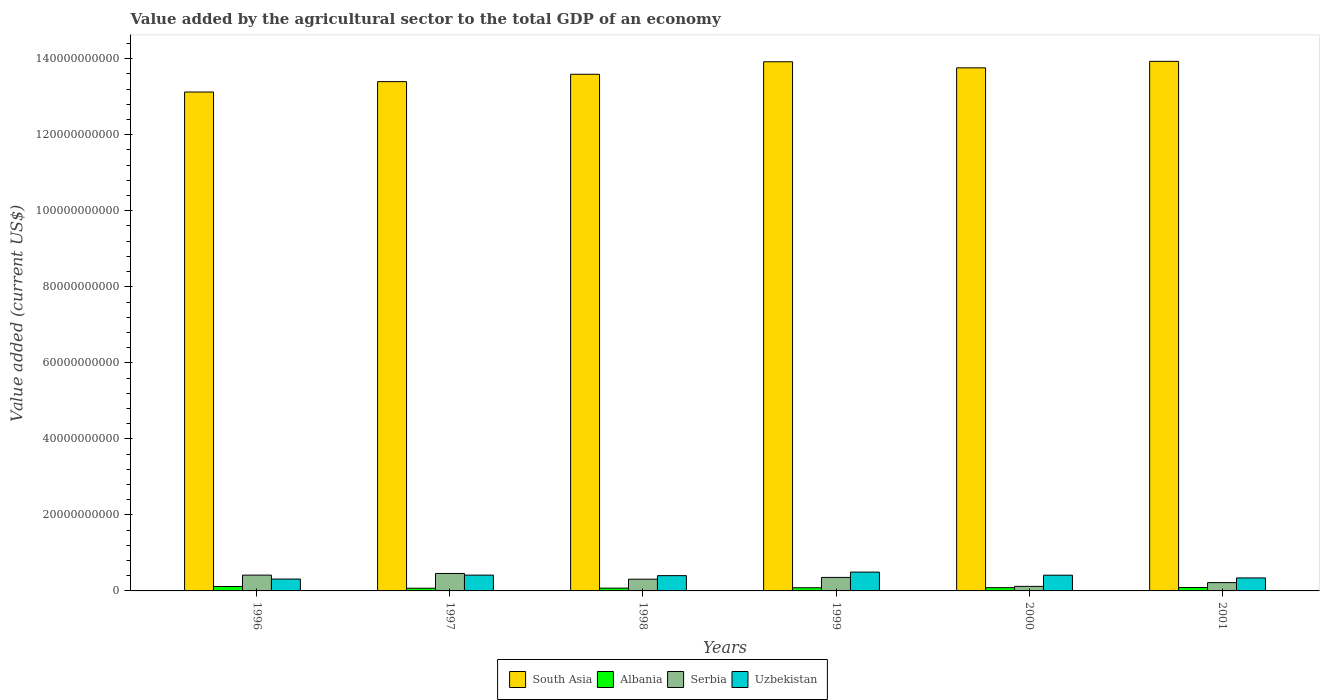How many bars are there on the 4th tick from the left?
Provide a short and direct response. 4. How many bars are there on the 4th tick from the right?
Your answer should be very brief. 4. What is the label of the 2nd group of bars from the left?
Your response must be concise. 1997. In how many cases, is the number of bars for a given year not equal to the number of legend labels?
Ensure brevity in your answer.  0. What is the value added by the agricultural sector to the total GDP in Uzbekistan in 1997?
Provide a succinct answer. 4.16e+09. Across all years, what is the maximum value added by the agricultural sector to the total GDP in Uzbekistan?
Provide a succinct answer. 4.96e+09. Across all years, what is the minimum value added by the agricultural sector to the total GDP in Uzbekistan?
Your answer should be compact. 3.12e+09. In which year was the value added by the agricultural sector to the total GDP in Serbia minimum?
Keep it short and to the point. 2000. What is the total value added by the agricultural sector to the total GDP in Albania in the graph?
Your response must be concise. 5.19e+09. What is the difference between the value added by the agricultural sector to the total GDP in Serbia in 1999 and that in 2001?
Offer a terse response. 1.37e+09. What is the difference between the value added by the agricultural sector to the total GDP in Albania in 1999 and the value added by the agricultural sector to the total GDP in Uzbekistan in 1996?
Provide a succinct answer. -2.29e+09. What is the average value added by the agricultural sector to the total GDP in Albania per year?
Your answer should be very brief. 8.65e+08. In the year 1996, what is the difference between the value added by the agricultural sector to the total GDP in Serbia and value added by the agricultural sector to the total GDP in Uzbekistan?
Ensure brevity in your answer.  1.04e+09. What is the ratio of the value added by the agricultural sector to the total GDP in Serbia in 1998 to that in 1999?
Offer a very short reply. 0.87. Is the value added by the agricultural sector to the total GDP in Albania in 1998 less than that in 2000?
Provide a succinct answer. Yes. What is the difference between the highest and the second highest value added by the agricultural sector to the total GDP in Albania?
Provide a short and direct response. 2.74e+08. What is the difference between the highest and the lowest value added by the agricultural sector to the total GDP in Uzbekistan?
Provide a short and direct response. 1.84e+09. Is the sum of the value added by the agricultural sector to the total GDP in Serbia in 1999 and 2001 greater than the maximum value added by the agricultural sector to the total GDP in South Asia across all years?
Make the answer very short. No. Is it the case that in every year, the sum of the value added by the agricultural sector to the total GDP in South Asia and value added by the agricultural sector to the total GDP in Albania is greater than the sum of value added by the agricultural sector to the total GDP in Serbia and value added by the agricultural sector to the total GDP in Uzbekistan?
Keep it short and to the point. Yes. What does the 1st bar from the right in 2000 represents?
Keep it short and to the point. Uzbekistan. How many bars are there?
Offer a very short reply. 24. Are all the bars in the graph horizontal?
Provide a short and direct response. No. Where does the legend appear in the graph?
Ensure brevity in your answer.  Bottom center. What is the title of the graph?
Offer a very short reply. Value added by the agricultural sector to the total GDP of an economy. What is the label or title of the X-axis?
Ensure brevity in your answer.  Years. What is the label or title of the Y-axis?
Keep it short and to the point. Value added (current US$). What is the Value added (current US$) in South Asia in 1996?
Offer a terse response. 1.31e+11. What is the Value added (current US$) in Albania in 1996?
Offer a terse response. 1.17e+09. What is the Value added (current US$) of Serbia in 1996?
Offer a very short reply. 4.16e+09. What is the Value added (current US$) in Uzbekistan in 1996?
Your answer should be very brief. 3.12e+09. What is the Value added (current US$) in South Asia in 1997?
Ensure brevity in your answer.  1.34e+11. What is the Value added (current US$) of Albania in 1997?
Give a very brief answer. 7.12e+08. What is the Value added (current US$) of Serbia in 1997?
Offer a terse response. 4.59e+09. What is the Value added (current US$) of Uzbekistan in 1997?
Keep it short and to the point. 4.16e+09. What is the Value added (current US$) of South Asia in 1998?
Your answer should be compact. 1.36e+11. What is the Value added (current US$) in Albania in 1998?
Your answer should be compact. 7.33e+08. What is the Value added (current US$) in Serbia in 1998?
Make the answer very short. 3.09e+09. What is the Value added (current US$) of Uzbekistan in 1998?
Provide a short and direct response. 4.02e+09. What is the Value added (current US$) of South Asia in 1999?
Your response must be concise. 1.39e+11. What is the Value added (current US$) of Albania in 1999?
Ensure brevity in your answer.  8.33e+08. What is the Value added (current US$) in Serbia in 1999?
Keep it short and to the point. 3.55e+09. What is the Value added (current US$) in Uzbekistan in 1999?
Your response must be concise. 4.96e+09. What is the Value added (current US$) of South Asia in 2000?
Your answer should be compact. 1.38e+11. What is the Value added (current US$) in Albania in 2000?
Keep it short and to the point. 8.53e+08. What is the Value added (current US$) of Serbia in 2000?
Your response must be concise. 1.20e+09. What is the Value added (current US$) of Uzbekistan in 2000?
Make the answer very short. 4.14e+09. What is the Value added (current US$) of South Asia in 2001?
Provide a succinct answer. 1.39e+11. What is the Value added (current US$) of Albania in 2001?
Give a very brief answer. 8.91e+08. What is the Value added (current US$) of Serbia in 2001?
Your answer should be very brief. 2.19e+09. What is the Value added (current US$) of Uzbekistan in 2001?
Make the answer very short. 3.42e+09. Across all years, what is the maximum Value added (current US$) of South Asia?
Offer a terse response. 1.39e+11. Across all years, what is the maximum Value added (current US$) in Albania?
Keep it short and to the point. 1.17e+09. Across all years, what is the maximum Value added (current US$) in Serbia?
Offer a terse response. 4.59e+09. Across all years, what is the maximum Value added (current US$) in Uzbekistan?
Keep it short and to the point. 4.96e+09. Across all years, what is the minimum Value added (current US$) of South Asia?
Give a very brief answer. 1.31e+11. Across all years, what is the minimum Value added (current US$) in Albania?
Make the answer very short. 7.12e+08. Across all years, what is the minimum Value added (current US$) in Serbia?
Your response must be concise. 1.20e+09. Across all years, what is the minimum Value added (current US$) in Uzbekistan?
Keep it short and to the point. 3.12e+09. What is the total Value added (current US$) in South Asia in the graph?
Keep it short and to the point. 8.17e+11. What is the total Value added (current US$) in Albania in the graph?
Ensure brevity in your answer.  5.19e+09. What is the total Value added (current US$) of Serbia in the graph?
Offer a terse response. 1.88e+1. What is the total Value added (current US$) of Uzbekistan in the graph?
Your answer should be very brief. 2.38e+1. What is the difference between the Value added (current US$) of South Asia in 1996 and that in 1997?
Your answer should be very brief. -2.74e+09. What is the difference between the Value added (current US$) in Albania in 1996 and that in 1997?
Make the answer very short. 4.53e+08. What is the difference between the Value added (current US$) of Serbia in 1996 and that in 1997?
Ensure brevity in your answer.  -4.31e+08. What is the difference between the Value added (current US$) of Uzbekistan in 1996 and that in 1997?
Your answer should be compact. -1.04e+09. What is the difference between the Value added (current US$) of South Asia in 1996 and that in 1998?
Ensure brevity in your answer.  -4.67e+09. What is the difference between the Value added (current US$) of Albania in 1996 and that in 1998?
Keep it short and to the point. 4.32e+08. What is the difference between the Value added (current US$) in Serbia in 1996 and that in 1998?
Your response must be concise. 1.07e+09. What is the difference between the Value added (current US$) in Uzbekistan in 1996 and that in 1998?
Your response must be concise. -8.97e+08. What is the difference between the Value added (current US$) of South Asia in 1996 and that in 1999?
Ensure brevity in your answer.  -7.96e+09. What is the difference between the Value added (current US$) of Albania in 1996 and that in 1999?
Provide a succinct answer. 3.32e+08. What is the difference between the Value added (current US$) in Serbia in 1996 and that in 1999?
Your answer should be compact. 6.08e+08. What is the difference between the Value added (current US$) of Uzbekistan in 1996 and that in 1999?
Make the answer very short. -1.84e+09. What is the difference between the Value added (current US$) of South Asia in 1996 and that in 2000?
Your answer should be compact. -6.36e+09. What is the difference between the Value added (current US$) of Albania in 1996 and that in 2000?
Offer a very short reply. 3.12e+08. What is the difference between the Value added (current US$) in Serbia in 1996 and that in 2000?
Ensure brevity in your answer.  2.96e+09. What is the difference between the Value added (current US$) in Uzbekistan in 1996 and that in 2000?
Provide a succinct answer. -1.02e+09. What is the difference between the Value added (current US$) of South Asia in 1996 and that in 2001?
Offer a terse response. -8.07e+09. What is the difference between the Value added (current US$) of Albania in 1996 and that in 2001?
Offer a very short reply. 2.74e+08. What is the difference between the Value added (current US$) in Serbia in 1996 and that in 2001?
Your response must be concise. 1.97e+09. What is the difference between the Value added (current US$) in Uzbekistan in 1996 and that in 2001?
Your response must be concise. -2.98e+08. What is the difference between the Value added (current US$) of South Asia in 1997 and that in 1998?
Give a very brief answer. -1.94e+09. What is the difference between the Value added (current US$) of Albania in 1997 and that in 1998?
Your answer should be compact. -2.05e+07. What is the difference between the Value added (current US$) in Serbia in 1997 and that in 1998?
Offer a terse response. 1.50e+09. What is the difference between the Value added (current US$) in Uzbekistan in 1997 and that in 1998?
Your response must be concise. 1.41e+08. What is the difference between the Value added (current US$) of South Asia in 1997 and that in 1999?
Offer a very short reply. -5.22e+09. What is the difference between the Value added (current US$) in Albania in 1997 and that in 1999?
Provide a succinct answer. -1.20e+08. What is the difference between the Value added (current US$) of Serbia in 1997 and that in 1999?
Keep it short and to the point. 1.04e+09. What is the difference between the Value added (current US$) in Uzbekistan in 1997 and that in 1999?
Your answer should be very brief. -7.99e+08. What is the difference between the Value added (current US$) of South Asia in 1997 and that in 2000?
Your answer should be very brief. -3.62e+09. What is the difference between the Value added (current US$) in Albania in 1997 and that in 2000?
Provide a succinct answer. -1.41e+08. What is the difference between the Value added (current US$) of Serbia in 1997 and that in 2000?
Your response must be concise. 3.39e+09. What is the difference between the Value added (current US$) of Uzbekistan in 1997 and that in 2000?
Keep it short and to the point. 2.19e+07. What is the difference between the Value added (current US$) of South Asia in 1997 and that in 2001?
Provide a short and direct response. -5.33e+09. What is the difference between the Value added (current US$) of Albania in 1997 and that in 2001?
Make the answer very short. -1.79e+08. What is the difference between the Value added (current US$) of Serbia in 1997 and that in 2001?
Make the answer very short. 2.40e+09. What is the difference between the Value added (current US$) of Uzbekistan in 1997 and that in 2001?
Ensure brevity in your answer.  7.40e+08. What is the difference between the Value added (current US$) in South Asia in 1998 and that in 1999?
Your response must be concise. -3.28e+09. What is the difference between the Value added (current US$) of Albania in 1998 and that in 1999?
Give a very brief answer. -9.98e+07. What is the difference between the Value added (current US$) in Serbia in 1998 and that in 1999?
Give a very brief answer. -4.63e+08. What is the difference between the Value added (current US$) of Uzbekistan in 1998 and that in 1999?
Provide a succinct answer. -9.40e+08. What is the difference between the Value added (current US$) in South Asia in 1998 and that in 2000?
Provide a short and direct response. -1.69e+09. What is the difference between the Value added (current US$) of Albania in 1998 and that in 2000?
Ensure brevity in your answer.  -1.21e+08. What is the difference between the Value added (current US$) of Serbia in 1998 and that in 2000?
Provide a succinct answer. 1.89e+09. What is the difference between the Value added (current US$) of Uzbekistan in 1998 and that in 2000?
Your answer should be compact. -1.19e+08. What is the difference between the Value added (current US$) of South Asia in 1998 and that in 2001?
Give a very brief answer. -3.40e+09. What is the difference between the Value added (current US$) in Albania in 1998 and that in 2001?
Provide a short and direct response. -1.58e+08. What is the difference between the Value added (current US$) of Serbia in 1998 and that in 2001?
Your response must be concise. 9.02e+08. What is the difference between the Value added (current US$) in Uzbekistan in 1998 and that in 2001?
Ensure brevity in your answer.  6.00e+08. What is the difference between the Value added (current US$) in South Asia in 1999 and that in 2000?
Offer a very short reply. 1.60e+09. What is the difference between the Value added (current US$) of Albania in 1999 and that in 2000?
Your answer should be very brief. -2.08e+07. What is the difference between the Value added (current US$) in Serbia in 1999 and that in 2000?
Offer a terse response. 2.35e+09. What is the difference between the Value added (current US$) of Uzbekistan in 1999 and that in 2000?
Ensure brevity in your answer.  8.21e+08. What is the difference between the Value added (current US$) in South Asia in 1999 and that in 2001?
Give a very brief answer. -1.12e+08. What is the difference between the Value added (current US$) of Albania in 1999 and that in 2001?
Offer a terse response. -5.86e+07. What is the difference between the Value added (current US$) of Serbia in 1999 and that in 2001?
Offer a very short reply. 1.37e+09. What is the difference between the Value added (current US$) of Uzbekistan in 1999 and that in 2001?
Provide a short and direct response. 1.54e+09. What is the difference between the Value added (current US$) in South Asia in 2000 and that in 2001?
Offer a very short reply. -1.71e+09. What is the difference between the Value added (current US$) in Albania in 2000 and that in 2001?
Provide a succinct answer. -3.78e+07. What is the difference between the Value added (current US$) in Serbia in 2000 and that in 2001?
Your response must be concise. -9.86e+08. What is the difference between the Value added (current US$) in Uzbekistan in 2000 and that in 2001?
Ensure brevity in your answer.  7.19e+08. What is the difference between the Value added (current US$) of South Asia in 1996 and the Value added (current US$) of Albania in 1997?
Provide a succinct answer. 1.31e+11. What is the difference between the Value added (current US$) of South Asia in 1996 and the Value added (current US$) of Serbia in 1997?
Keep it short and to the point. 1.27e+11. What is the difference between the Value added (current US$) in South Asia in 1996 and the Value added (current US$) in Uzbekistan in 1997?
Your answer should be compact. 1.27e+11. What is the difference between the Value added (current US$) in Albania in 1996 and the Value added (current US$) in Serbia in 1997?
Provide a short and direct response. -3.43e+09. What is the difference between the Value added (current US$) in Albania in 1996 and the Value added (current US$) in Uzbekistan in 1997?
Provide a short and direct response. -2.99e+09. What is the difference between the Value added (current US$) in Serbia in 1996 and the Value added (current US$) in Uzbekistan in 1997?
Give a very brief answer. 1.05e+06. What is the difference between the Value added (current US$) of South Asia in 1996 and the Value added (current US$) of Albania in 1998?
Your response must be concise. 1.31e+11. What is the difference between the Value added (current US$) of South Asia in 1996 and the Value added (current US$) of Serbia in 1998?
Your answer should be compact. 1.28e+11. What is the difference between the Value added (current US$) in South Asia in 1996 and the Value added (current US$) in Uzbekistan in 1998?
Keep it short and to the point. 1.27e+11. What is the difference between the Value added (current US$) in Albania in 1996 and the Value added (current US$) in Serbia in 1998?
Provide a succinct answer. -1.92e+09. What is the difference between the Value added (current US$) in Albania in 1996 and the Value added (current US$) in Uzbekistan in 1998?
Provide a short and direct response. -2.85e+09. What is the difference between the Value added (current US$) in Serbia in 1996 and the Value added (current US$) in Uzbekistan in 1998?
Ensure brevity in your answer.  1.42e+08. What is the difference between the Value added (current US$) in South Asia in 1996 and the Value added (current US$) in Albania in 1999?
Your answer should be very brief. 1.30e+11. What is the difference between the Value added (current US$) of South Asia in 1996 and the Value added (current US$) of Serbia in 1999?
Offer a terse response. 1.28e+11. What is the difference between the Value added (current US$) in South Asia in 1996 and the Value added (current US$) in Uzbekistan in 1999?
Keep it short and to the point. 1.26e+11. What is the difference between the Value added (current US$) of Albania in 1996 and the Value added (current US$) of Serbia in 1999?
Make the answer very short. -2.39e+09. What is the difference between the Value added (current US$) of Albania in 1996 and the Value added (current US$) of Uzbekistan in 1999?
Provide a short and direct response. -3.79e+09. What is the difference between the Value added (current US$) in Serbia in 1996 and the Value added (current US$) in Uzbekistan in 1999?
Your answer should be compact. -7.98e+08. What is the difference between the Value added (current US$) of South Asia in 1996 and the Value added (current US$) of Albania in 2000?
Provide a succinct answer. 1.30e+11. What is the difference between the Value added (current US$) of South Asia in 1996 and the Value added (current US$) of Serbia in 2000?
Ensure brevity in your answer.  1.30e+11. What is the difference between the Value added (current US$) of South Asia in 1996 and the Value added (current US$) of Uzbekistan in 2000?
Your answer should be compact. 1.27e+11. What is the difference between the Value added (current US$) of Albania in 1996 and the Value added (current US$) of Serbia in 2000?
Your response must be concise. -3.46e+07. What is the difference between the Value added (current US$) of Albania in 1996 and the Value added (current US$) of Uzbekistan in 2000?
Offer a very short reply. -2.97e+09. What is the difference between the Value added (current US$) in Serbia in 1996 and the Value added (current US$) in Uzbekistan in 2000?
Offer a terse response. 2.30e+07. What is the difference between the Value added (current US$) in South Asia in 1996 and the Value added (current US$) in Albania in 2001?
Provide a short and direct response. 1.30e+11. What is the difference between the Value added (current US$) in South Asia in 1996 and the Value added (current US$) in Serbia in 2001?
Provide a short and direct response. 1.29e+11. What is the difference between the Value added (current US$) in South Asia in 1996 and the Value added (current US$) in Uzbekistan in 2001?
Ensure brevity in your answer.  1.28e+11. What is the difference between the Value added (current US$) in Albania in 1996 and the Value added (current US$) in Serbia in 2001?
Make the answer very short. -1.02e+09. What is the difference between the Value added (current US$) of Albania in 1996 and the Value added (current US$) of Uzbekistan in 2001?
Offer a very short reply. -2.25e+09. What is the difference between the Value added (current US$) of Serbia in 1996 and the Value added (current US$) of Uzbekistan in 2001?
Make the answer very short. 7.41e+08. What is the difference between the Value added (current US$) in South Asia in 1997 and the Value added (current US$) in Albania in 1998?
Offer a terse response. 1.33e+11. What is the difference between the Value added (current US$) of South Asia in 1997 and the Value added (current US$) of Serbia in 1998?
Your response must be concise. 1.31e+11. What is the difference between the Value added (current US$) in South Asia in 1997 and the Value added (current US$) in Uzbekistan in 1998?
Keep it short and to the point. 1.30e+11. What is the difference between the Value added (current US$) in Albania in 1997 and the Value added (current US$) in Serbia in 1998?
Give a very brief answer. -2.38e+09. What is the difference between the Value added (current US$) in Albania in 1997 and the Value added (current US$) in Uzbekistan in 1998?
Your answer should be very brief. -3.30e+09. What is the difference between the Value added (current US$) in Serbia in 1997 and the Value added (current US$) in Uzbekistan in 1998?
Provide a succinct answer. 5.73e+08. What is the difference between the Value added (current US$) in South Asia in 1997 and the Value added (current US$) in Albania in 1999?
Make the answer very short. 1.33e+11. What is the difference between the Value added (current US$) of South Asia in 1997 and the Value added (current US$) of Serbia in 1999?
Your answer should be compact. 1.30e+11. What is the difference between the Value added (current US$) of South Asia in 1997 and the Value added (current US$) of Uzbekistan in 1999?
Your response must be concise. 1.29e+11. What is the difference between the Value added (current US$) of Albania in 1997 and the Value added (current US$) of Serbia in 1999?
Provide a short and direct response. -2.84e+09. What is the difference between the Value added (current US$) of Albania in 1997 and the Value added (current US$) of Uzbekistan in 1999?
Your answer should be very brief. -4.24e+09. What is the difference between the Value added (current US$) in Serbia in 1997 and the Value added (current US$) in Uzbekistan in 1999?
Make the answer very short. -3.66e+08. What is the difference between the Value added (current US$) in South Asia in 1997 and the Value added (current US$) in Albania in 2000?
Offer a terse response. 1.33e+11. What is the difference between the Value added (current US$) in South Asia in 1997 and the Value added (current US$) in Serbia in 2000?
Offer a terse response. 1.33e+11. What is the difference between the Value added (current US$) in South Asia in 1997 and the Value added (current US$) in Uzbekistan in 2000?
Your answer should be very brief. 1.30e+11. What is the difference between the Value added (current US$) in Albania in 1997 and the Value added (current US$) in Serbia in 2000?
Keep it short and to the point. -4.87e+08. What is the difference between the Value added (current US$) in Albania in 1997 and the Value added (current US$) in Uzbekistan in 2000?
Provide a short and direct response. -3.42e+09. What is the difference between the Value added (current US$) of Serbia in 1997 and the Value added (current US$) of Uzbekistan in 2000?
Offer a terse response. 4.54e+08. What is the difference between the Value added (current US$) in South Asia in 1997 and the Value added (current US$) in Albania in 2001?
Your answer should be compact. 1.33e+11. What is the difference between the Value added (current US$) of South Asia in 1997 and the Value added (current US$) of Serbia in 2001?
Make the answer very short. 1.32e+11. What is the difference between the Value added (current US$) in South Asia in 1997 and the Value added (current US$) in Uzbekistan in 2001?
Keep it short and to the point. 1.31e+11. What is the difference between the Value added (current US$) in Albania in 1997 and the Value added (current US$) in Serbia in 2001?
Keep it short and to the point. -1.47e+09. What is the difference between the Value added (current US$) in Albania in 1997 and the Value added (current US$) in Uzbekistan in 2001?
Your answer should be compact. -2.70e+09. What is the difference between the Value added (current US$) in Serbia in 1997 and the Value added (current US$) in Uzbekistan in 2001?
Ensure brevity in your answer.  1.17e+09. What is the difference between the Value added (current US$) of South Asia in 1998 and the Value added (current US$) of Albania in 1999?
Offer a terse response. 1.35e+11. What is the difference between the Value added (current US$) in South Asia in 1998 and the Value added (current US$) in Serbia in 1999?
Provide a short and direct response. 1.32e+11. What is the difference between the Value added (current US$) of South Asia in 1998 and the Value added (current US$) of Uzbekistan in 1999?
Keep it short and to the point. 1.31e+11. What is the difference between the Value added (current US$) of Albania in 1998 and the Value added (current US$) of Serbia in 1999?
Your answer should be very brief. -2.82e+09. What is the difference between the Value added (current US$) in Albania in 1998 and the Value added (current US$) in Uzbekistan in 1999?
Your answer should be very brief. -4.22e+09. What is the difference between the Value added (current US$) of Serbia in 1998 and the Value added (current US$) of Uzbekistan in 1999?
Ensure brevity in your answer.  -1.87e+09. What is the difference between the Value added (current US$) in South Asia in 1998 and the Value added (current US$) in Albania in 2000?
Give a very brief answer. 1.35e+11. What is the difference between the Value added (current US$) in South Asia in 1998 and the Value added (current US$) in Serbia in 2000?
Make the answer very short. 1.35e+11. What is the difference between the Value added (current US$) of South Asia in 1998 and the Value added (current US$) of Uzbekistan in 2000?
Your answer should be compact. 1.32e+11. What is the difference between the Value added (current US$) of Albania in 1998 and the Value added (current US$) of Serbia in 2000?
Your response must be concise. -4.67e+08. What is the difference between the Value added (current US$) of Albania in 1998 and the Value added (current US$) of Uzbekistan in 2000?
Offer a terse response. -3.40e+09. What is the difference between the Value added (current US$) in Serbia in 1998 and the Value added (current US$) in Uzbekistan in 2000?
Your answer should be compact. -1.05e+09. What is the difference between the Value added (current US$) of South Asia in 1998 and the Value added (current US$) of Albania in 2001?
Your response must be concise. 1.35e+11. What is the difference between the Value added (current US$) in South Asia in 1998 and the Value added (current US$) in Serbia in 2001?
Offer a terse response. 1.34e+11. What is the difference between the Value added (current US$) of South Asia in 1998 and the Value added (current US$) of Uzbekistan in 2001?
Your answer should be very brief. 1.32e+11. What is the difference between the Value added (current US$) in Albania in 1998 and the Value added (current US$) in Serbia in 2001?
Provide a succinct answer. -1.45e+09. What is the difference between the Value added (current US$) of Albania in 1998 and the Value added (current US$) of Uzbekistan in 2001?
Your answer should be compact. -2.68e+09. What is the difference between the Value added (current US$) of Serbia in 1998 and the Value added (current US$) of Uzbekistan in 2001?
Keep it short and to the point. -3.29e+08. What is the difference between the Value added (current US$) in South Asia in 1999 and the Value added (current US$) in Albania in 2000?
Your answer should be very brief. 1.38e+11. What is the difference between the Value added (current US$) of South Asia in 1999 and the Value added (current US$) of Serbia in 2000?
Give a very brief answer. 1.38e+11. What is the difference between the Value added (current US$) of South Asia in 1999 and the Value added (current US$) of Uzbekistan in 2000?
Your response must be concise. 1.35e+11. What is the difference between the Value added (current US$) of Albania in 1999 and the Value added (current US$) of Serbia in 2000?
Your answer should be very brief. -3.67e+08. What is the difference between the Value added (current US$) in Albania in 1999 and the Value added (current US$) in Uzbekistan in 2000?
Provide a short and direct response. -3.30e+09. What is the difference between the Value added (current US$) of Serbia in 1999 and the Value added (current US$) of Uzbekistan in 2000?
Your response must be concise. -5.85e+08. What is the difference between the Value added (current US$) in South Asia in 1999 and the Value added (current US$) in Albania in 2001?
Keep it short and to the point. 1.38e+11. What is the difference between the Value added (current US$) in South Asia in 1999 and the Value added (current US$) in Serbia in 2001?
Provide a succinct answer. 1.37e+11. What is the difference between the Value added (current US$) of South Asia in 1999 and the Value added (current US$) of Uzbekistan in 2001?
Ensure brevity in your answer.  1.36e+11. What is the difference between the Value added (current US$) in Albania in 1999 and the Value added (current US$) in Serbia in 2001?
Keep it short and to the point. -1.35e+09. What is the difference between the Value added (current US$) of Albania in 1999 and the Value added (current US$) of Uzbekistan in 2001?
Your answer should be very brief. -2.58e+09. What is the difference between the Value added (current US$) of Serbia in 1999 and the Value added (current US$) of Uzbekistan in 2001?
Your response must be concise. 1.34e+08. What is the difference between the Value added (current US$) of South Asia in 2000 and the Value added (current US$) of Albania in 2001?
Make the answer very short. 1.37e+11. What is the difference between the Value added (current US$) in South Asia in 2000 and the Value added (current US$) in Serbia in 2001?
Give a very brief answer. 1.35e+11. What is the difference between the Value added (current US$) of South Asia in 2000 and the Value added (current US$) of Uzbekistan in 2001?
Your answer should be compact. 1.34e+11. What is the difference between the Value added (current US$) in Albania in 2000 and the Value added (current US$) in Serbia in 2001?
Provide a short and direct response. -1.33e+09. What is the difference between the Value added (current US$) in Albania in 2000 and the Value added (current US$) in Uzbekistan in 2001?
Your answer should be compact. -2.56e+09. What is the difference between the Value added (current US$) of Serbia in 2000 and the Value added (current US$) of Uzbekistan in 2001?
Provide a short and direct response. -2.22e+09. What is the average Value added (current US$) of South Asia per year?
Give a very brief answer. 1.36e+11. What is the average Value added (current US$) of Albania per year?
Your answer should be compact. 8.65e+08. What is the average Value added (current US$) of Serbia per year?
Your answer should be compact. 3.13e+09. What is the average Value added (current US$) in Uzbekistan per year?
Offer a very short reply. 3.97e+09. In the year 1996, what is the difference between the Value added (current US$) of South Asia and Value added (current US$) of Albania?
Offer a terse response. 1.30e+11. In the year 1996, what is the difference between the Value added (current US$) in South Asia and Value added (current US$) in Serbia?
Your answer should be compact. 1.27e+11. In the year 1996, what is the difference between the Value added (current US$) of South Asia and Value added (current US$) of Uzbekistan?
Offer a very short reply. 1.28e+11. In the year 1996, what is the difference between the Value added (current US$) of Albania and Value added (current US$) of Serbia?
Offer a terse response. -2.99e+09. In the year 1996, what is the difference between the Value added (current US$) of Albania and Value added (current US$) of Uzbekistan?
Give a very brief answer. -1.95e+09. In the year 1996, what is the difference between the Value added (current US$) of Serbia and Value added (current US$) of Uzbekistan?
Give a very brief answer. 1.04e+09. In the year 1997, what is the difference between the Value added (current US$) of South Asia and Value added (current US$) of Albania?
Provide a short and direct response. 1.33e+11. In the year 1997, what is the difference between the Value added (current US$) in South Asia and Value added (current US$) in Serbia?
Ensure brevity in your answer.  1.29e+11. In the year 1997, what is the difference between the Value added (current US$) of South Asia and Value added (current US$) of Uzbekistan?
Offer a terse response. 1.30e+11. In the year 1997, what is the difference between the Value added (current US$) of Albania and Value added (current US$) of Serbia?
Provide a short and direct response. -3.88e+09. In the year 1997, what is the difference between the Value added (current US$) of Albania and Value added (current US$) of Uzbekistan?
Keep it short and to the point. -3.45e+09. In the year 1997, what is the difference between the Value added (current US$) of Serbia and Value added (current US$) of Uzbekistan?
Ensure brevity in your answer.  4.33e+08. In the year 1998, what is the difference between the Value added (current US$) in South Asia and Value added (current US$) in Albania?
Provide a short and direct response. 1.35e+11. In the year 1998, what is the difference between the Value added (current US$) in South Asia and Value added (current US$) in Serbia?
Make the answer very short. 1.33e+11. In the year 1998, what is the difference between the Value added (current US$) in South Asia and Value added (current US$) in Uzbekistan?
Your answer should be very brief. 1.32e+11. In the year 1998, what is the difference between the Value added (current US$) in Albania and Value added (current US$) in Serbia?
Offer a terse response. -2.36e+09. In the year 1998, what is the difference between the Value added (current US$) of Albania and Value added (current US$) of Uzbekistan?
Ensure brevity in your answer.  -3.28e+09. In the year 1998, what is the difference between the Value added (current US$) of Serbia and Value added (current US$) of Uzbekistan?
Provide a short and direct response. -9.29e+08. In the year 1999, what is the difference between the Value added (current US$) in South Asia and Value added (current US$) in Albania?
Ensure brevity in your answer.  1.38e+11. In the year 1999, what is the difference between the Value added (current US$) of South Asia and Value added (current US$) of Serbia?
Provide a short and direct response. 1.36e+11. In the year 1999, what is the difference between the Value added (current US$) in South Asia and Value added (current US$) in Uzbekistan?
Offer a very short reply. 1.34e+11. In the year 1999, what is the difference between the Value added (current US$) of Albania and Value added (current US$) of Serbia?
Keep it short and to the point. -2.72e+09. In the year 1999, what is the difference between the Value added (current US$) of Albania and Value added (current US$) of Uzbekistan?
Keep it short and to the point. -4.12e+09. In the year 1999, what is the difference between the Value added (current US$) of Serbia and Value added (current US$) of Uzbekistan?
Offer a terse response. -1.41e+09. In the year 2000, what is the difference between the Value added (current US$) of South Asia and Value added (current US$) of Albania?
Provide a succinct answer. 1.37e+11. In the year 2000, what is the difference between the Value added (current US$) in South Asia and Value added (current US$) in Serbia?
Your response must be concise. 1.36e+11. In the year 2000, what is the difference between the Value added (current US$) of South Asia and Value added (current US$) of Uzbekistan?
Make the answer very short. 1.33e+11. In the year 2000, what is the difference between the Value added (current US$) in Albania and Value added (current US$) in Serbia?
Offer a very short reply. -3.46e+08. In the year 2000, what is the difference between the Value added (current US$) of Albania and Value added (current US$) of Uzbekistan?
Offer a very short reply. -3.28e+09. In the year 2000, what is the difference between the Value added (current US$) of Serbia and Value added (current US$) of Uzbekistan?
Your answer should be very brief. -2.94e+09. In the year 2001, what is the difference between the Value added (current US$) of South Asia and Value added (current US$) of Albania?
Your response must be concise. 1.38e+11. In the year 2001, what is the difference between the Value added (current US$) in South Asia and Value added (current US$) in Serbia?
Offer a terse response. 1.37e+11. In the year 2001, what is the difference between the Value added (current US$) in South Asia and Value added (current US$) in Uzbekistan?
Make the answer very short. 1.36e+11. In the year 2001, what is the difference between the Value added (current US$) of Albania and Value added (current US$) of Serbia?
Make the answer very short. -1.29e+09. In the year 2001, what is the difference between the Value added (current US$) in Albania and Value added (current US$) in Uzbekistan?
Your answer should be very brief. -2.53e+09. In the year 2001, what is the difference between the Value added (current US$) in Serbia and Value added (current US$) in Uzbekistan?
Ensure brevity in your answer.  -1.23e+09. What is the ratio of the Value added (current US$) in South Asia in 1996 to that in 1997?
Provide a succinct answer. 0.98. What is the ratio of the Value added (current US$) of Albania in 1996 to that in 1997?
Provide a short and direct response. 1.64. What is the ratio of the Value added (current US$) in Serbia in 1996 to that in 1997?
Give a very brief answer. 0.91. What is the ratio of the Value added (current US$) in Uzbekistan in 1996 to that in 1997?
Ensure brevity in your answer.  0.75. What is the ratio of the Value added (current US$) in South Asia in 1996 to that in 1998?
Your answer should be very brief. 0.97. What is the ratio of the Value added (current US$) in Albania in 1996 to that in 1998?
Provide a succinct answer. 1.59. What is the ratio of the Value added (current US$) in Serbia in 1996 to that in 1998?
Make the answer very short. 1.35. What is the ratio of the Value added (current US$) in Uzbekistan in 1996 to that in 1998?
Make the answer very short. 0.78. What is the ratio of the Value added (current US$) of South Asia in 1996 to that in 1999?
Keep it short and to the point. 0.94. What is the ratio of the Value added (current US$) in Albania in 1996 to that in 1999?
Provide a succinct answer. 1.4. What is the ratio of the Value added (current US$) in Serbia in 1996 to that in 1999?
Offer a terse response. 1.17. What is the ratio of the Value added (current US$) in Uzbekistan in 1996 to that in 1999?
Your answer should be very brief. 0.63. What is the ratio of the Value added (current US$) in South Asia in 1996 to that in 2000?
Your response must be concise. 0.95. What is the ratio of the Value added (current US$) in Albania in 1996 to that in 2000?
Your response must be concise. 1.37. What is the ratio of the Value added (current US$) in Serbia in 1996 to that in 2000?
Offer a terse response. 3.47. What is the ratio of the Value added (current US$) of Uzbekistan in 1996 to that in 2000?
Provide a succinct answer. 0.75. What is the ratio of the Value added (current US$) in South Asia in 1996 to that in 2001?
Your response must be concise. 0.94. What is the ratio of the Value added (current US$) in Albania in 1996 to that in 2001?
Your answer should be very brief. 1.31. What is the ratio of the Value added (current US$) of Serbia in 1996 to that in 2001?
Offer a terse response. 1.9. What is the ratio of the Value added (current US$) of Uzbekistan in 1996 to that in 2001?
Ensure brevity in your answer.  0.91. What is the ratio of the Value added (current US$) of South Asia in 1997 to that in 1998?
Ensure brevity in your answer.  0.99. What is the ratio of the Value added (current US$) in Albania in 1997 to that in 1998?
Offer a terse response. 0.97. What is the ratio of the Value added (current US$) in Serbia in 1997 to that in 1998?
Ensure brevity in your answer.  1.49. What is the ratio of the Value added (current US$) in Uzbekistan in 1997 to that in 1998?
Give a very brief answer. 1.03. What is the ratio of the Value added (current US$) of South Asia in 1997 to that in 1999?
Your answer should be very brief. 0.96. What is the ratio of the Value added (current US$) in Albania in 1997 to that in 1999?
Keep it short and to the point. 0.86. What is the ratio of the Value added (current US$) of Serbia in 1997 to that in 1999?
Provide a succinct answer. 1.29. What is the ratio of the Value added (current US$) of Uzbekistan in 1997 to that in 1999?
Offer a terse response. 0.84. What is the ratio of the Value added (current US$) in South Asia in 1997 to that in 2000?
Your response must be concise. 0.97. What is the ratio of the Value added (current US$) in Albania in 1997 to that in 2000?
Offer a very short reply. 0.83. What is the ratio of the Value added (current US$) of Serbia in 1997 to that in 2000?
Provide a short and direct response. 3.83. What is the ratio of the Value added (current US$) of Uzbekistan in 1997 to that in 2000?
Your answer should be compact. 1.01. What is the ratio of the Value added (current US$) in South Asia in 1997 to that in 2001?
Give a very brief answer. 0.96. What is the ratio of the Value added (current US$) of Albania in 1997 to that in 2001?
Provide a succinct answer. 0.8. What is the ratio of the Value added (current US$) of Serbia in 1997 to that in 2001?
Your response must be concise. 2.1. What is the ratio of the Value added (current US$) in Uzbekistan in 1997 to that in 2001?
Your response must be concise. 1.22. What is the ratio of the Value added (current US$) of South Asia in 1998 to that in 1999?
Your answer should be very brief. 0.98. What is the ratio of the Value added (current US$) in Albania in 1998 to that in 1999?
Ensure brevity in your answer.  0.88. What is the ratio of the Value added (current US$) of Serbia in 1998 to that in 1999?
Your answer should be very brief. 0.87. What is the ratio of the Value added (current US$) of Uzbekistan in 1998 to that in 1999?
Your response must be concise. 0.81. What is the ratio of the Value added (current US$) in South Asia in 1998 to that in 2000?
Keep it short and to the point. 0.99. What is the ratio of the Value added (current US$) of Albania in 1998 to that in 2000?
Your response must be concise. 0.86. What is the ratio of the Value added (current US$) of Serbia in 1998 to that in 2000?
Offer a very short reply. 2.57. What is the ratio of the Value added (current US$) of Uzbekistan in 1998 to that in 2000?
Your answer should be compact. 0.97. What is the ratio of the Value added (current US$) in South Asia in 1998 to that in 2001?
Ensure brevity in your answer.  0.98. What is the ratio of the Value added (current US$) in Albania in 1998 to that in 2001?
Give a very brief answer. 0.82. What is the ratio of the Value added (current US$) in Serbia in 1998 to that in 2001?
Offer a terse response. 1.41. What is the ratio of the Value added (current US$) of Uzbekistan in 1998 to that in 2001?
Provide a succinct answer. 1.18. What is the ratio of the Value added (current US$) in South Asia in 1999 to that in 2000?
Make the answer very short. 1.01. What is the ratio of the Value added (current US$) of Albania in 1999 to that in 2000?
Your answer should be compact. 0.98. What is the ratio of the Value added (current US$) in Serbia in 1999 to that in 2000?
Your answer should be very brief. 2.96. What is the ratio of the Value added (current US$) of Uzbekistan in 1999 to that in 2000?
Your answer should be very brief. 1.2. What is the ratio of the Value added (current US$) of Albania in 1999 to that in 2001?
Keep it short and to the point. 0.93. What is the ratio of the Value added (current US$) of Serbia in 1999 to that in 2001?
Your answer should be very brief. 1.62. What is the ratio of the Value added (current US$) of Uzbekistan in 1999 to that in 2001?
Give a very brief answer. 1.45. What is the ratio of the Value added (current US$) of Albania in 2000 to that in 2001?
Ensure brevity in your answer.  0.96. What is the ratio of the Value added (current US$) in Serbia in 2000 to that in 2001?
Make the answer very short. 0.55. What is the ratio of the Value added (current US$) in Uzbekistan in 2000 to that in 2001?
Keep it short and to the point. 1.21. What is the difference between the highest and the second highest Value added (current US$) in South Asia?
Ensure brevity in your answer.  1.12e+08. What is the difference between the highest and the second highest Value added (current US$) in Albania?
Ensure brevity in your answer.  2.74e+08. What is the difference between the highest and the second highest Value added (current US$) of Serbia?
Offer a terse response. 4.31e+08. What is the difference between the highest and the second highest Value added (current US$) of Uzbekistan?
Ensure brevity in your answer.  7.99e+08. What is the difference between the highest and the lowest Value added (current US$) of South Asia?
Provide a short and direct response. 8.07e+09. What is the difference between the highest and the lowest Value added (current US$) in Albania?
Give a very brief answer. 4.53e+08. What is the difference between the highest and the lowest Value added (current US$) of Serbia?
Keep it short and to the point. 3.39e+09. What is the difference between the highest and the lowest Value added (current US$) in Uzbekistan?
Give a very brief answer. 1.84e+09. 